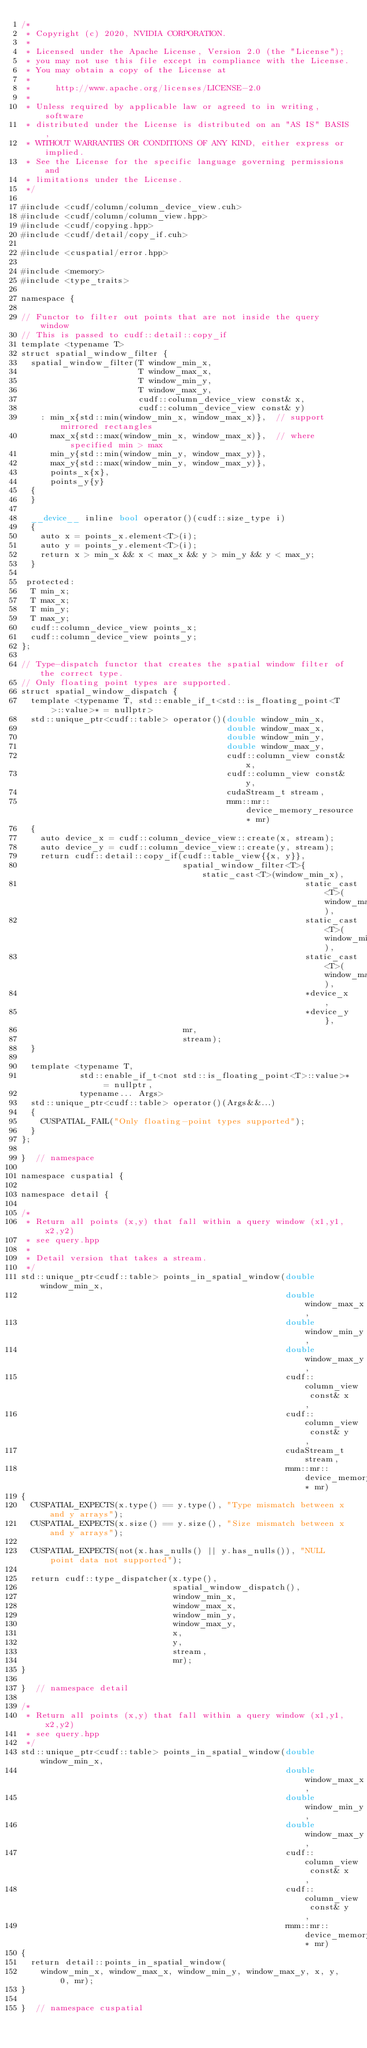<code> <loc_0><loc_0><loc_500><loc_500><_Cuda_>/*
 * Copyright (c) 2020, NVIDIA CORPORATION.
 *
 * Licensed under the Apache License, Version 2.0 (the "License");
 * you may not use this file except in compliance with the License.
 * You may obtain a copy of the License at
 *
 *     http://www.apache.org/licenses/LICENSE-2.0
 *
 * Unless required by applicable law or agreed to in writing, software
 * distributed under the License is distributed on an "AS IS" BASIS,
 * WITHOUT WARRANTIES OR CONDITIONS OF ANY KIND, either express or implied.
 * See the License for the specific language governing permissions and
 * limitations under the License.
 */

#include <cudf/column/column_device_view.cuh>
#include <cudf/column/column_view.hpp>
#include <cudf/copying.hpp>
#include <cudf/detail/copy_if.cuh>

#include <cuspatial/error.hpp>

#include <memory>
#include <type_traits>

namespace {

// Functor to filter out points that are not inside the query window
// This is passed to cudf::detail::copy_if
template <typename T>
struct spatial_window_filter {
  spatial_window_filter(T window_min_x,
                        T window_max_x,
                        T window_min_y,
                        T window_max_y,
                        cudf::column_device_view const& x,
                        cudf::column_device_view const& y)
    : min_x{std::min(window_min_x, window_max_x)},  // support mirrored rectangles
      max_x{std::max(window_min_x, window_max_x)},  // where specified min > max
      min_y{std::min(window_min_y, window_max_y)},
      max_y{std::max(window_min_y, window_max_y)},
      points_x{x},
      points_y{y}
  {
  }

  __device__ inline bool operator()(cudf::size_type i)
  {
    auto x = points_x.element<T>(i);
    auto y = points_y.element<T>(i);
    return x > min_x && x < max_x && y > min_y && y < max_y;
  }

 protected:
  T min_x;
  T max_x;
  T min_y;
  T max_y;
  cudf::column_device_view points_x;
  cudf::column_device_view points_y;
};

// Type-dispatch functor that creates the spatial window filter of the correct type.
// Only floating point types are supported.
struct spatial_window_dispatch {
  template <typename T, std::enable_if_t<std::is_floating_point<T>::value>* = nullptr>
  std::unique_ptr<cudf::table> operator()(double window_min_x,
                                          double window_max_x,
                                          double window_min_y,
                                          double window_max_y,
                                          cudf::column_view const& x,
                                          cudf::column_view const& y,
                                          cudaStream_t stream,
                                          rmm::mr::device_memory_resource* mr)
  {
    auto device_x = cudf::column_device_view::create(x, stream);
    auto device_y = cudf::column_device_view::create(y, stream);
    return cudf::detail::copy_if(cudf::table_view{{x, y}},
                                 spatial_window_filter<T>{static_cast<T>(window_min_x),
                                                          static_cast<T>(window_max_x),
                                                          static_cast<T>(window_min_y),
                                                          static_cast<T>(window_max_y),
                                                          *device_x,
                                                          *device_y},
                                 mr,
                                 stream);
  }

  template <typename T,
            std::enable_if_t<not std::is_floating_point<T>::value>* = nullptr,
            typename... Args>
  std::unique_ptr<cudf::table> operator()(Args&&...)
  {
    CUSPATIAL_FAIL("Only floating-point types supported");
  }
};

}  // namespace

namespace cuspatial {

namespace detail {

/*
 * Return all points (x,y) that fall within a query window (x1,y1,x2,y2)
 * see query.hpp
 *
 * Detail version that takes a stream.
 */
std::unique_ptr<cudf::table> points_in_spatial_window(double window_min_x,
                                                      double window_max_x,
                                                      double window_min_y,
                                                      double window_max_y,
                                                      cudf::column_view const& x,
                                                      cudf::column_view const& y,
                                                      cudaStream_t stream,
                                                      rmm::mr::device_memory_resource* mr)
{
  CUSPATIAL_EXPECTS(x.type() == y.type(), "Type mismatch between x and y arrays");
  CUSPATIAL_EXPECTS(x.size() == y.size(), "Size mismatch between x and y arrays");

  CUSPATIAL_EXPECTS(not(x.has_nulls() || y.has_nulls()), "NULL point data not supported");

  return cudf::type_dispatcher(x.type(),
                               spatial_window_dispatch(),
                               window_min_x,
                               window_max_x,
                               window_min_y,
                               window_max_y,
                               x,
                               y,
                               stream,
                               mr);
}

}  // namespace detail

/*
 * Return all points (x,y) that fall within a query window (x1,y1,x2,y2)
 * see query.hpp
 */
std::unique_ptr<cudf::table> points_in_spatial_window(double window_min_x,
                                                      double window_max_x,
                                                      double window_min_y,
                                                      double window_max_y,
                                                      cudf::column_view const& x,
                                                      cudf::column_view const& y,
                                                      rmm::mr::device_memory_resource* mr)
{
  return detail::points_in_spatial_window(
    window_min_x, window_max_x, window_min_y, window_max_y, x, y, 0, mr);
}

}  // namespace cuspatial
</code> 